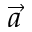Convert formula to latex. <formula><loc_0><loc_0><loc_500><loc_500>\vec { a }</formula> 